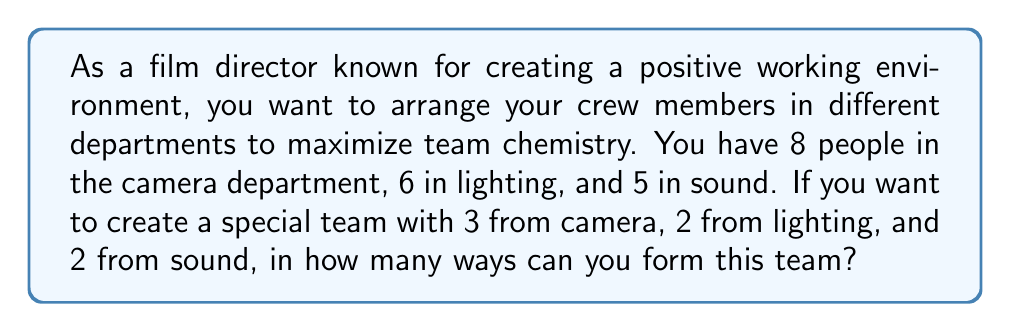What is the answer to this math problem? Let's approach this step-by-step using the multiplication principle of counting:

1) For the camera department:
   We need to choose 3 people out of 8. This is a combination problem.
   Number of ways = $\binom{8}{3} = \frac{8!}{3!(8-3)!} = \frac{8!}{3!5!} = 56$

2) For the lighting department:
   We need to choose 2 people out of 6.
   Number of ways = $\binom{6}{2} = \frac{6!}{2!(6-2)!} = \frac{6!}{2!4!} = 15$

3) For the sound department:
   We need to choose 2 people out of 5.
   Number of ways = $\binom{5}{2} = \frac{5!}{2!(5-2)!} = \frac{5!}{2!3!} = 10$

4) By the multiplication principle, the total number of ways to form the team is:
   $56 \times 15 \times 10 = 8,400$

This calculation gives us all possible combinations of crew members from each department, allowing for maximum flexibility in creating a harmonious team.
Answer: 8,400 ways 